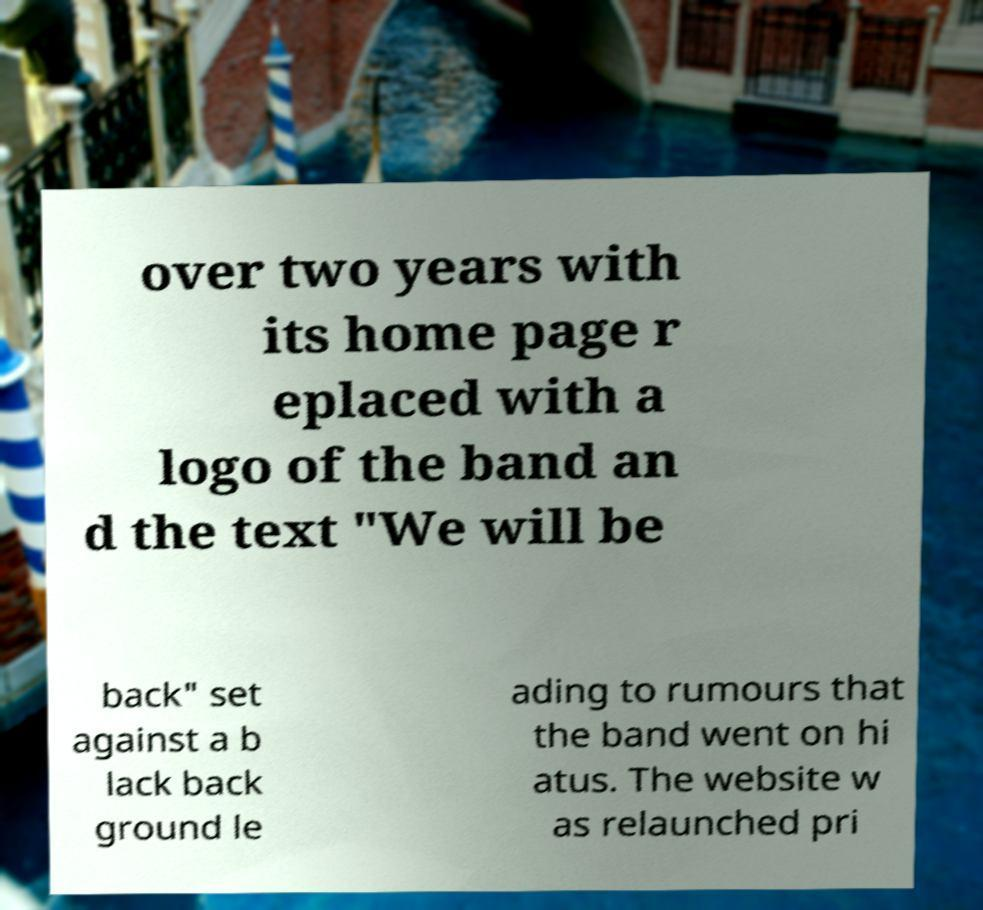There's text embedded in this image that I need extracted. Can you transcribe it verbatim? over two years with its home page r eplaced with a logo of the band an d the text "We will be back" set against a b lack back ground le ading to rumours that the band went on hi atus. The website w as relaunched pri 